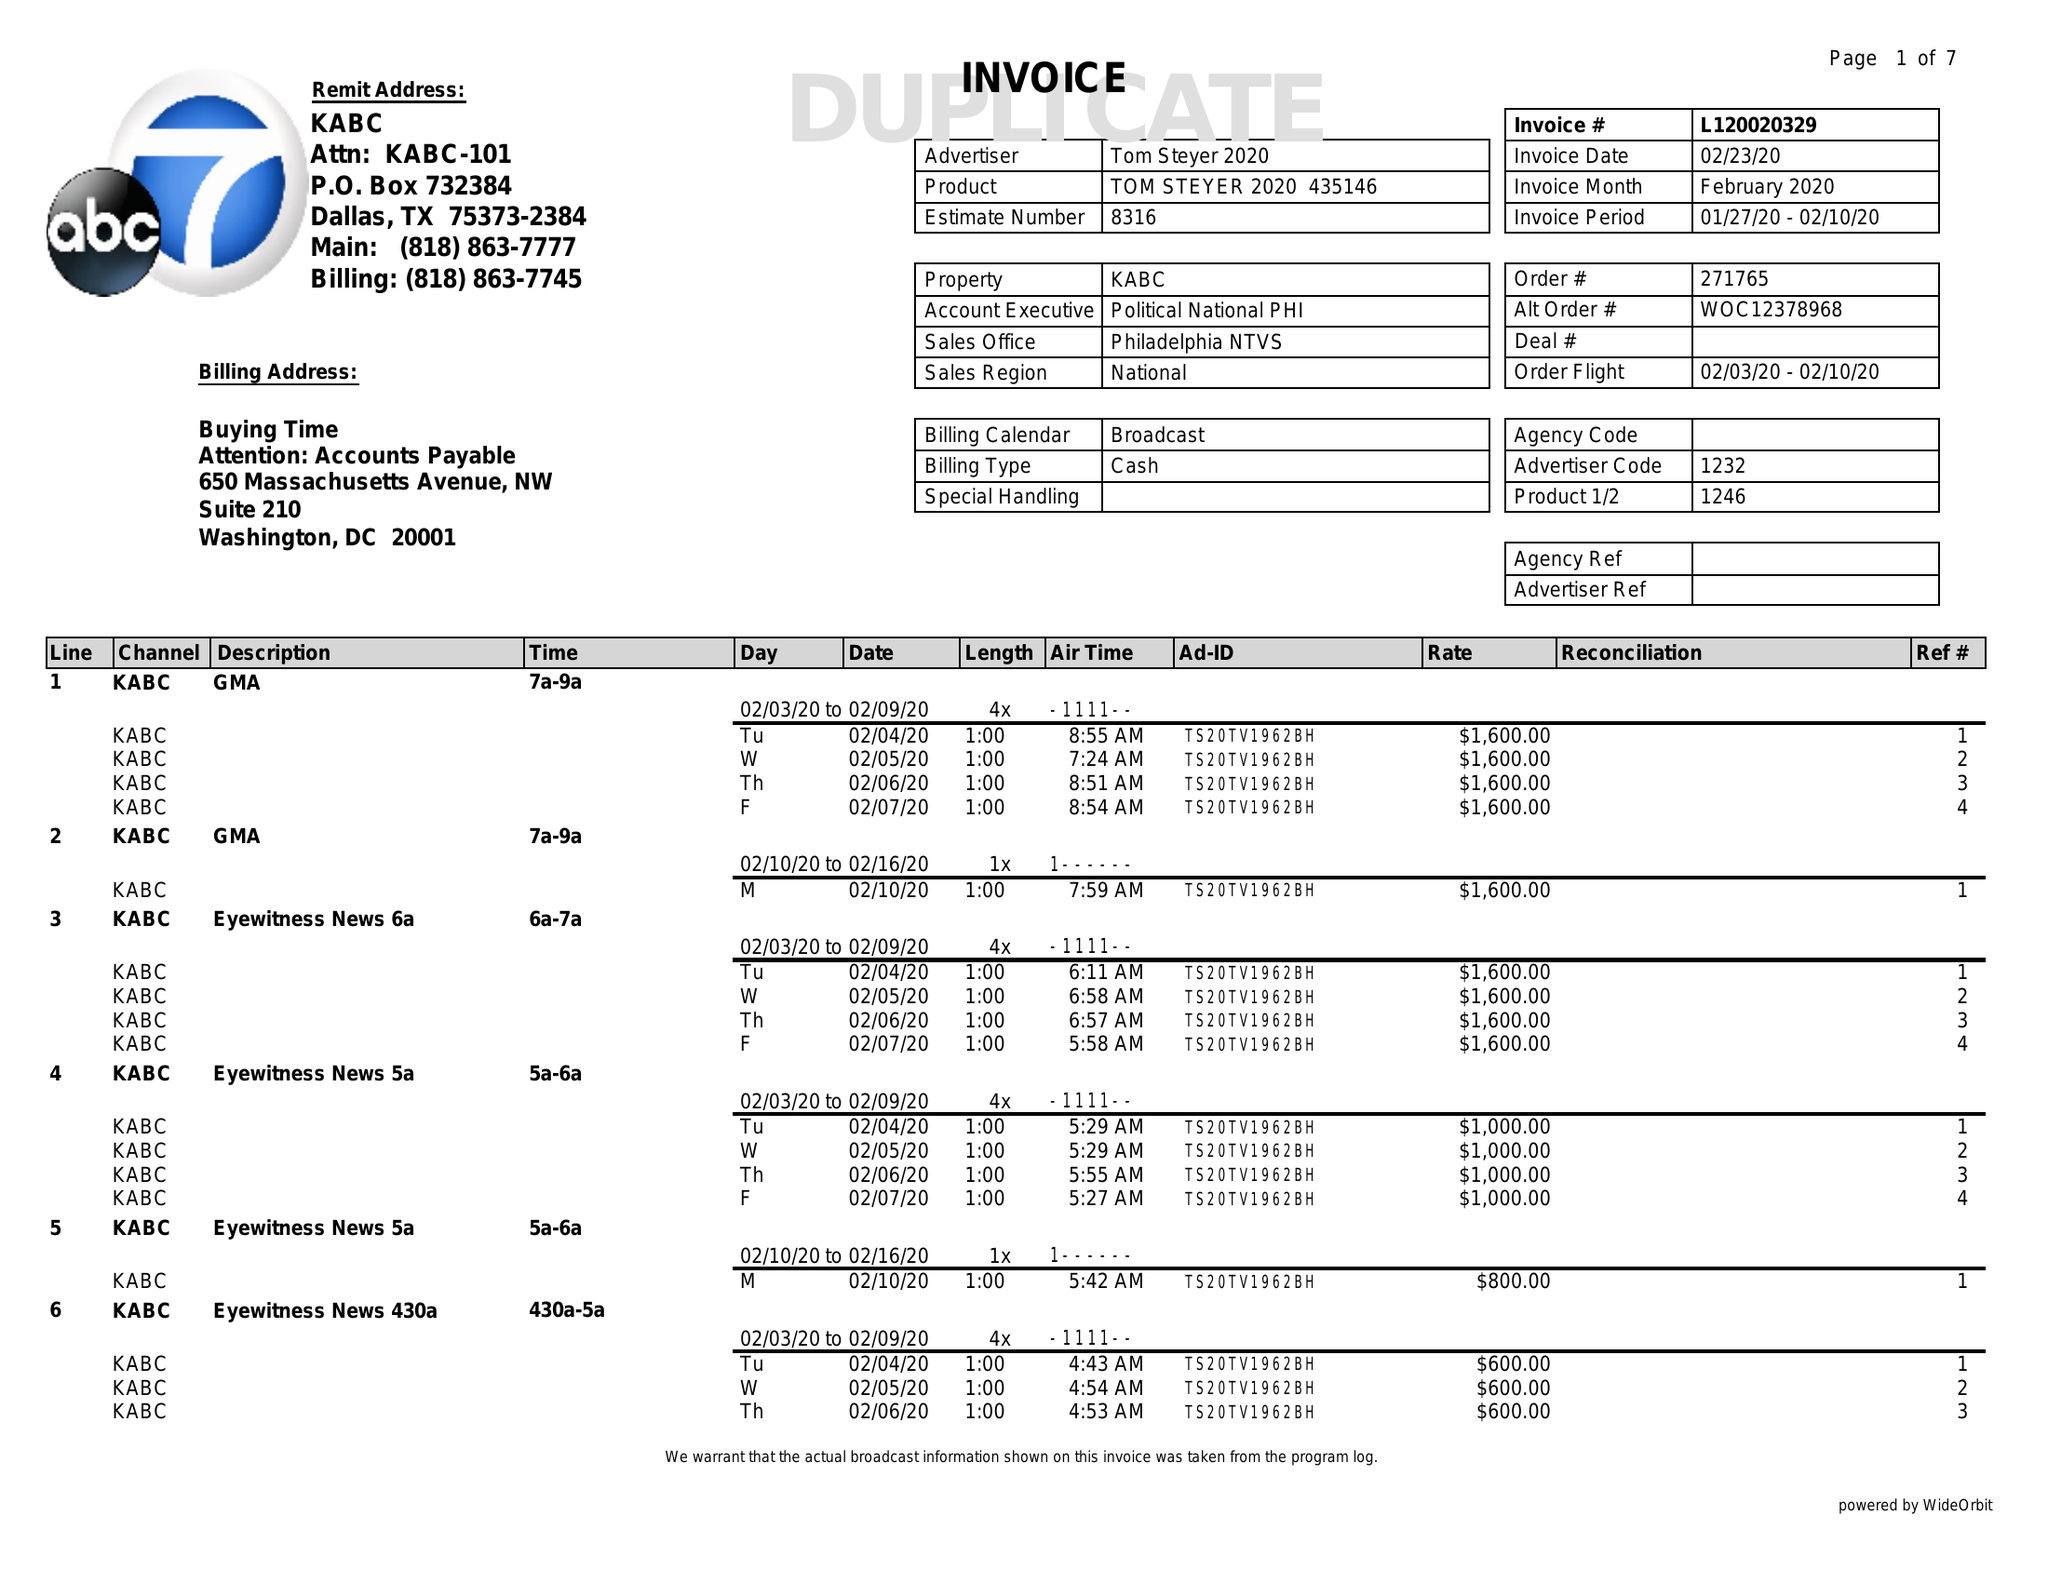What is the value for the gross_amount?
Answer the question using a single word or phrase. 147400.00 